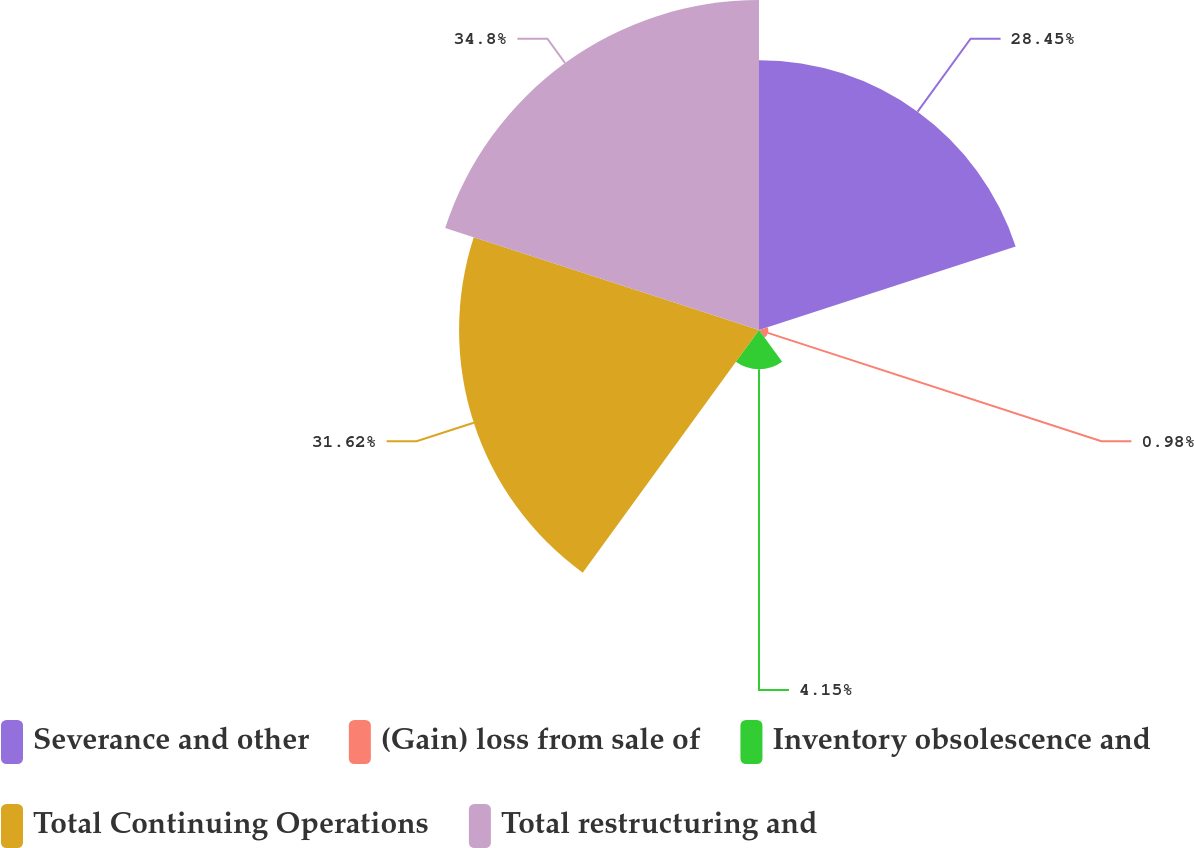Convert chart. <chart><loc_0><loc_0><loc_500><loc_500><pie_chart><fcel>Severance and other<fcel>(Gain) loss from sale of<fcel>Inventory obsolescence and<fcel>Total Continuing Operations<fcel>Total restructuring and<nl><fcel>28.45%<fcel>0.98%<fcel>4.15%<fcel>31.62%<fcel>34.79%<nl></chart> 